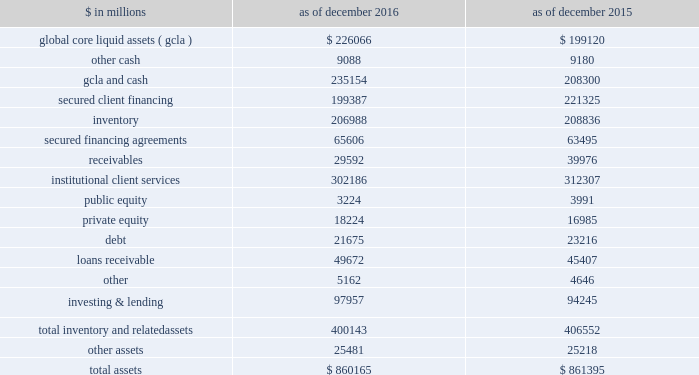The goldman sachs group , inc .
And subsidiaries management 2019s discussion and analysis scenario analyses .
We conduct various scenario analyses including as part of the comprehensive capital analysis and review ( ccar ) and dodd-frank act stress tests ( dfast ) , as well as our resolution and recovery planning .
See 201cequity capital management and regulatory capital 2014 equity capital management 201d below for further information about these scenario analyses .
These scenarios cover short-term and long-term time horizons using various macroeconomic and firm-specific assumptions , based on a range of economic scenarios .
We use these analyses to assist us in developing our longer-term balance sheet management strategy , including the level and composition of assets , funding and equity capital .
Additionally , these analyses help us develop approaches for maintaining appropriate funding , liquidity and capital across a variety of situations , including a severely stressed environment .
Balance sheet allocation in addition to preparing our consolidated statements of financial condition in accordance with u.s .
Gaap , we prepare a balance sheet that generally allocates assets to our businesses , which is a non-gaap presentation and may not be comparable to similar non-gaap presentations used by other companies .
We believe that presenting our assets on this basis is meaningful because it is consistent with the way management views and manages risks associated with our assets and better enables investors to assess the liquidity of our assets .
The table below presents our balance sheet allocation. .
The following is a description of the captions in the table above : 2030 global core liquid assets and cash .
We maintain liquidity to meet a broad range of potential cash outflows and collateral needs in a stressed environment .
See 201cliquidity risk management 201d below for details on the composition and sizing of our 201cglobal core liquid assets 201d ( gcla ) .
In addition to our gcla , we maintain other unrestricted operating cash balances , primarily for use in specific currencies , entities , or jurisdictions where we do not have immediate access to parent company liquidity .
2030 secured client financing .
We provide collateralized financing for client positions , including margin loans secured by client collateral , securities borrowed , and resale agreements primarily collateralized by government obligations .
We segregate cash and securities for regulatory and other purposes related to client activity .
Securities are segregated from our own inventory as well as from collateral obtained through securities borrowed or resale agreements .
Our secured client financing arrangements , which are generally short-term , are accounted for at fair value or at amounts that approximate fair value , and include daily margin requirements to mitigate counterparty credit risk .
2030 institutional client services .
In institutional client services , we maintain inventory positions to facilitate market making in fixed income , equity , currency and commodity products .
Additionally , as part of market- making activities , we enter into resale or securities borrowing arrangements to obtain securities or use our own inventory to cover transactions in which we or our clients have sold securities that have not yet been purchased .
The receivables in institutional client services primarily relate to securities transactions .
2030 investing & lending .
In investing & lending , we make investments and originate loans to provide financing to clients .
These investments and loans are typically longer- term in nature .
We make investments , directly and indirectly through funds that we manage , in debt securities , loans , public and private equity securities , infrastructure , real estate entities and other investments .
We also make unsecured loans to individuals through our online platform .
Debt includes $ 14.23 billion and $ 17.29 billion as of december 2016 and december 2015 , respectively , of direct loans primarily extended to corporate and private wealth management clients that are accounted for at fair value .
Loans receivable is comprised of loans held for investment that are accounted for at amortized cost net of allowance for loan losses .
See note 9 to the consolidated financial statements for further information about loans receivable .
Goldman sachs 2016 form 10-k 67 .
What is the debt-to-total asset ratio in 2015? 
Computations: (23216 / 861395)
Answer: 0.02695. 